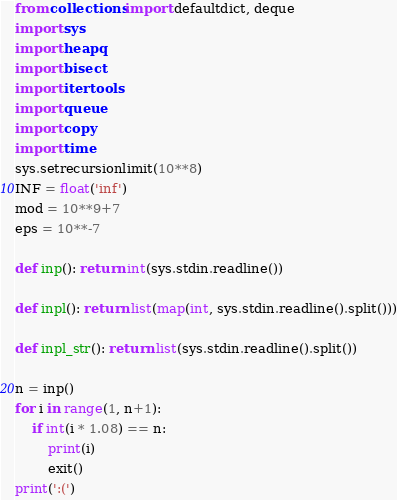<code> <loc_0><loc_0><loc_500><loc_500><_Python_>from collections import defaultdict, deque
import sys
import heapq
import bisect
import itertools
import queue
import copy
import time
sys.setrecursionlimit(10**8)
INF = float('inf')
mod = 10**9+7
eps = 10**-7

def inp(): return int(sys.stdin.readline())

def inpl(): return list(map(int, sys.stdin.readline().split()))

def inpl_str(): return list(sys.stdin.readline().split())

n = inp()
for i in range(1, n+1):
    if int(i * 1.08) == n:
        print(i)
        exit()
print(':(')</code> 